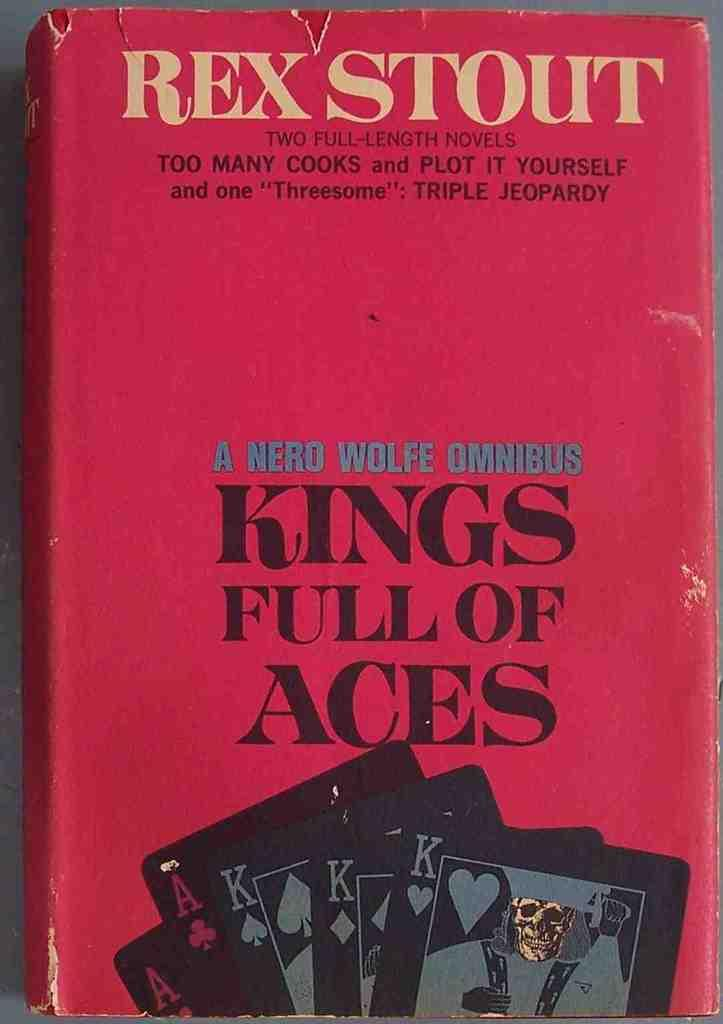<image>
Summarize the visual content of the image. A red book titled Kings Full of Aces 